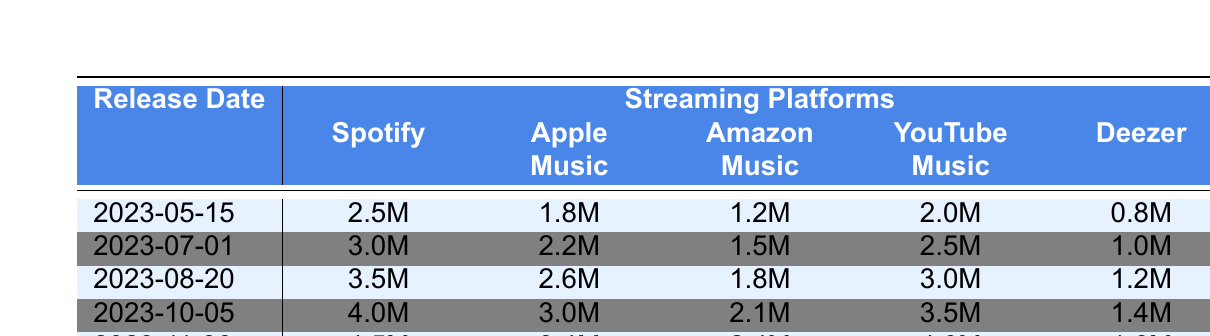What song had the highest number of streams on Spotify? Looking at the row for Spotify, the song "Starlight Serenade" has the highest number of streams listed, with 4.5 million.
Answer: 4.5 million Which platform had the lowest streams for "Summer Nights"? The lowest number of streams for "Summer Nights" can be found in the Deezer column, which shows 800,000 streams.
Answer: 800,000 What is the total number of streams for "Heartbeat" across all platforms? Summing the streams for "Heartbeat": 3,000,000 (Spotify) + 2,200,000 (Apple Music) + 1,500,000 (Amazon Music) + 2,500,000 (YouTube Music) + 1,000,000 (Deezer) gives a total of 10,200,000 streams.
Answer: 10,200,000 Did "Neon Dreams" receive more streams on YouTube Music than on Apple Music? Yes, "Neon Dreams" received 3,000,000 streams on YouTube Music and 2,600,000 streams on Apple Music, meaning it did get more streams on YouTube Music.
Answer: Yes Which song had the biggest increase in streams from 2023-07-01 to 2023-08-20 on Spotify? The streaming data for Spotify shows "Heartbeat" with 3,000,000 streams on 2023-07-01 and "Neon Dreams" with 3,500,000 streams on 2023-08-20. The increase is 3,500,000 - 3,000,000 = 500,000, which is higher than the increase for other songs during this period.
Answer: "Neon Dreams" What was the average number of streams across all platforms for the song "Autumn Whisper"? To find the average, first sum the streams: 4,000,000 (Spotify) + 3,000,000 (Apple Music) + 2,100,000 (Amazon Music) + 3,500,000 (YouTube Music) + 1,400,000 (Deezer) = 13,000,000. Then, divide by the number of platforms (5), giving an average of 13,000,000 / 5 = 2,600,000 streams.
Answer: 2,600,000 Which release date had the most total streams across all platforms? Summing the streams for each date, "2023-11-30" has the highest sum of 4.5M + 3.4M + 2.4M + 4.0M + 1.6M = 16.9M, higher than any other release date.
Answer: 2023-11-30 Is it true that Deezer had more streams for "Starlight Serenade" than for "Heartbeat"? No, Deezer had 1,600,000 streams for "Starlight Serenade" and only 1,000,000 for "Heartbeat", indicating that "Starlight Serenade" had more streams.
Answer: Yes What percentage of total streams on Apple Music is attributed to "Neon Dreams"? The total for Apple Music is 8,800,000 (2.6M for "Neon Dreams" among others). The percentage is (2,600,000 / 8,800,000) * 100 = 29.55% (approximately 29.6%).
Answer: 29.6% 